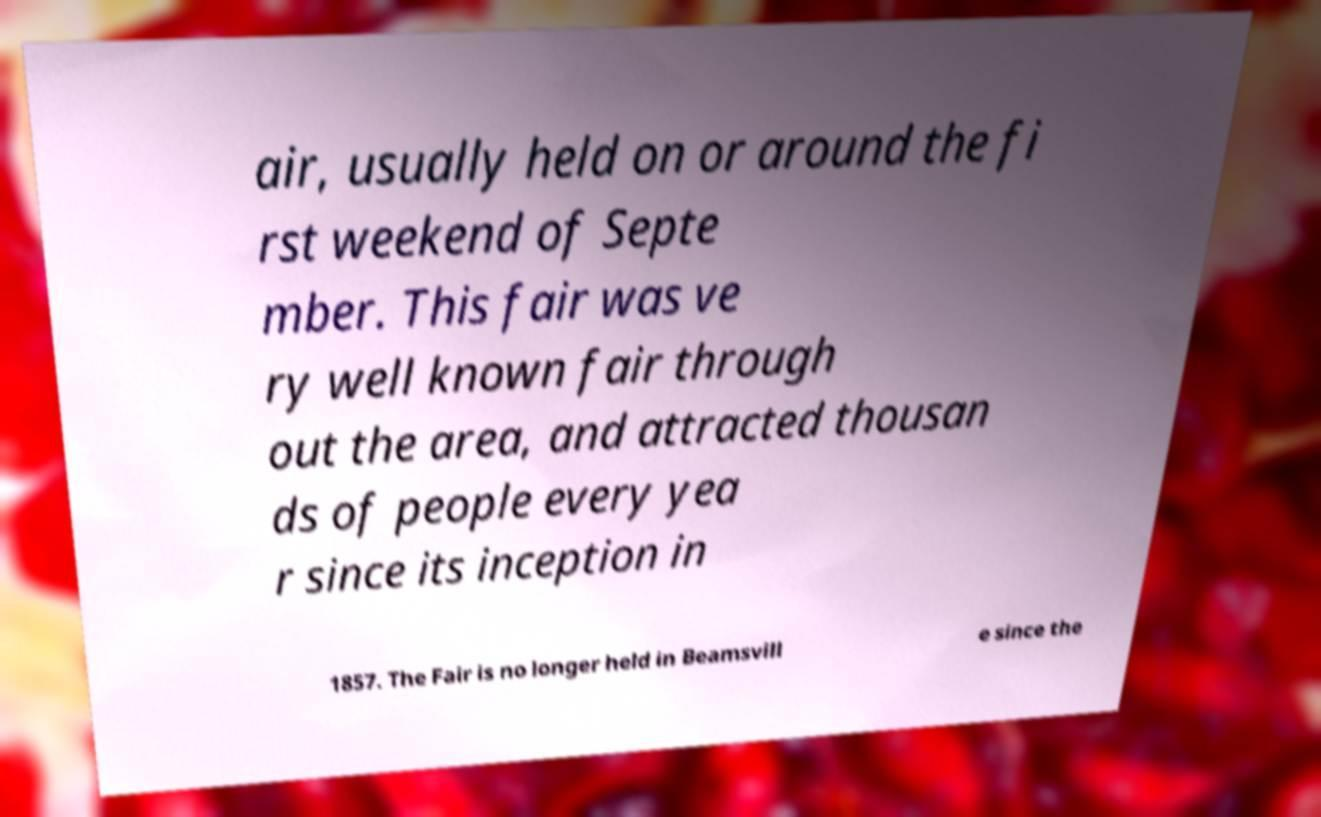Please read and relay the text visible in this image. What does it say? air, usually held on or around the fi rst weekend of Septe mber. This fair was ve ry well known fair through out the area, and attracted thousan ds of people every yea r since its inception in 1857. The Fair is no longer held in Beamsvill e since the 